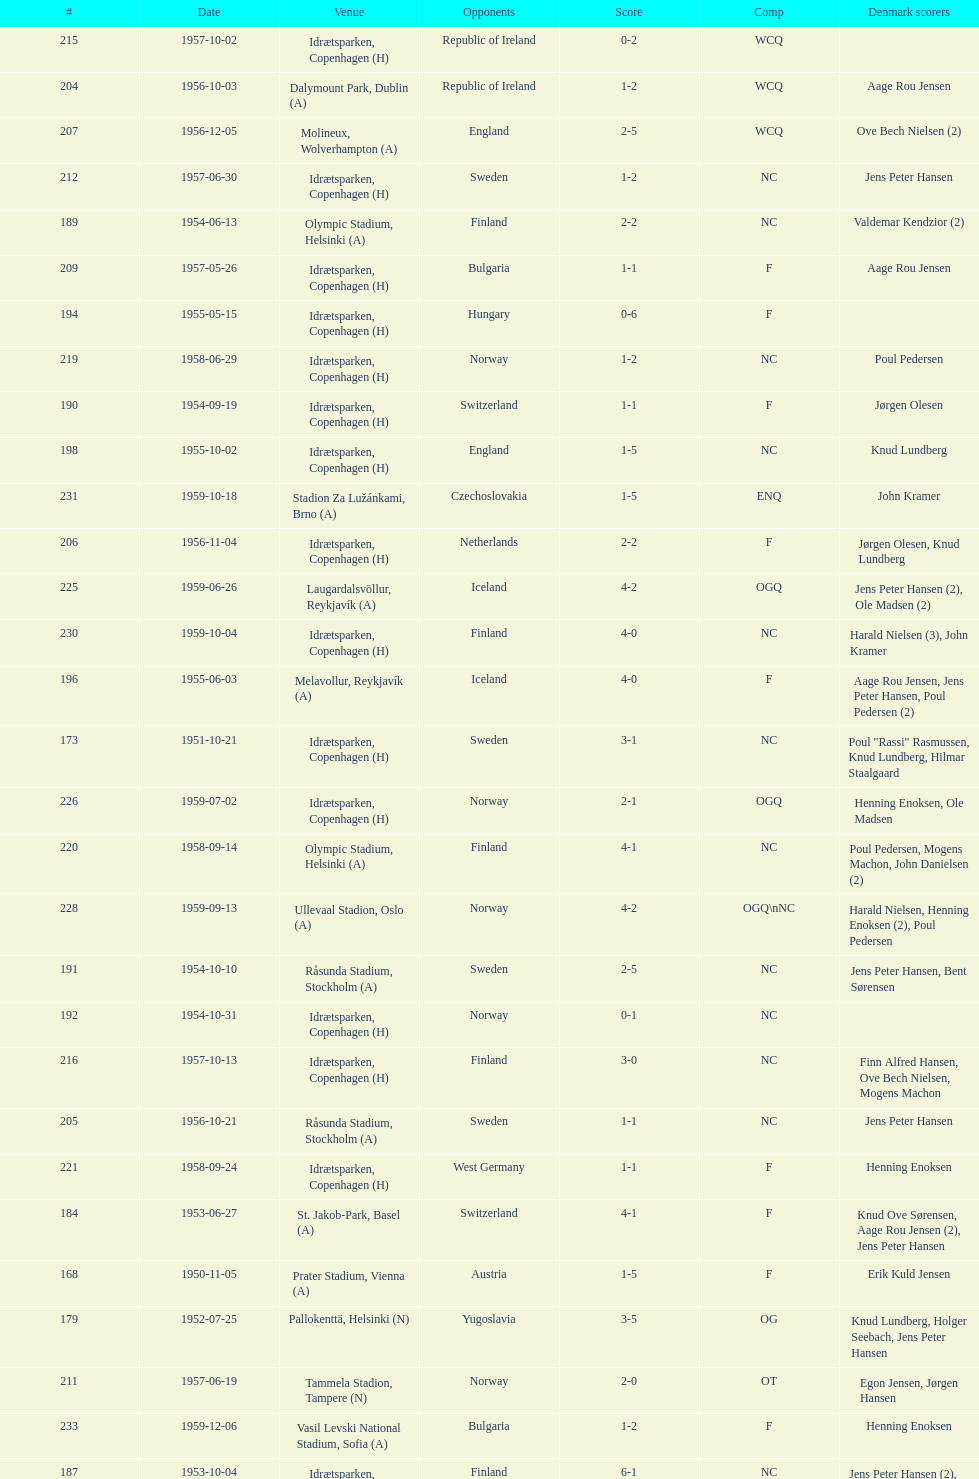Which total score was higher, game #163 or #181? 163. 